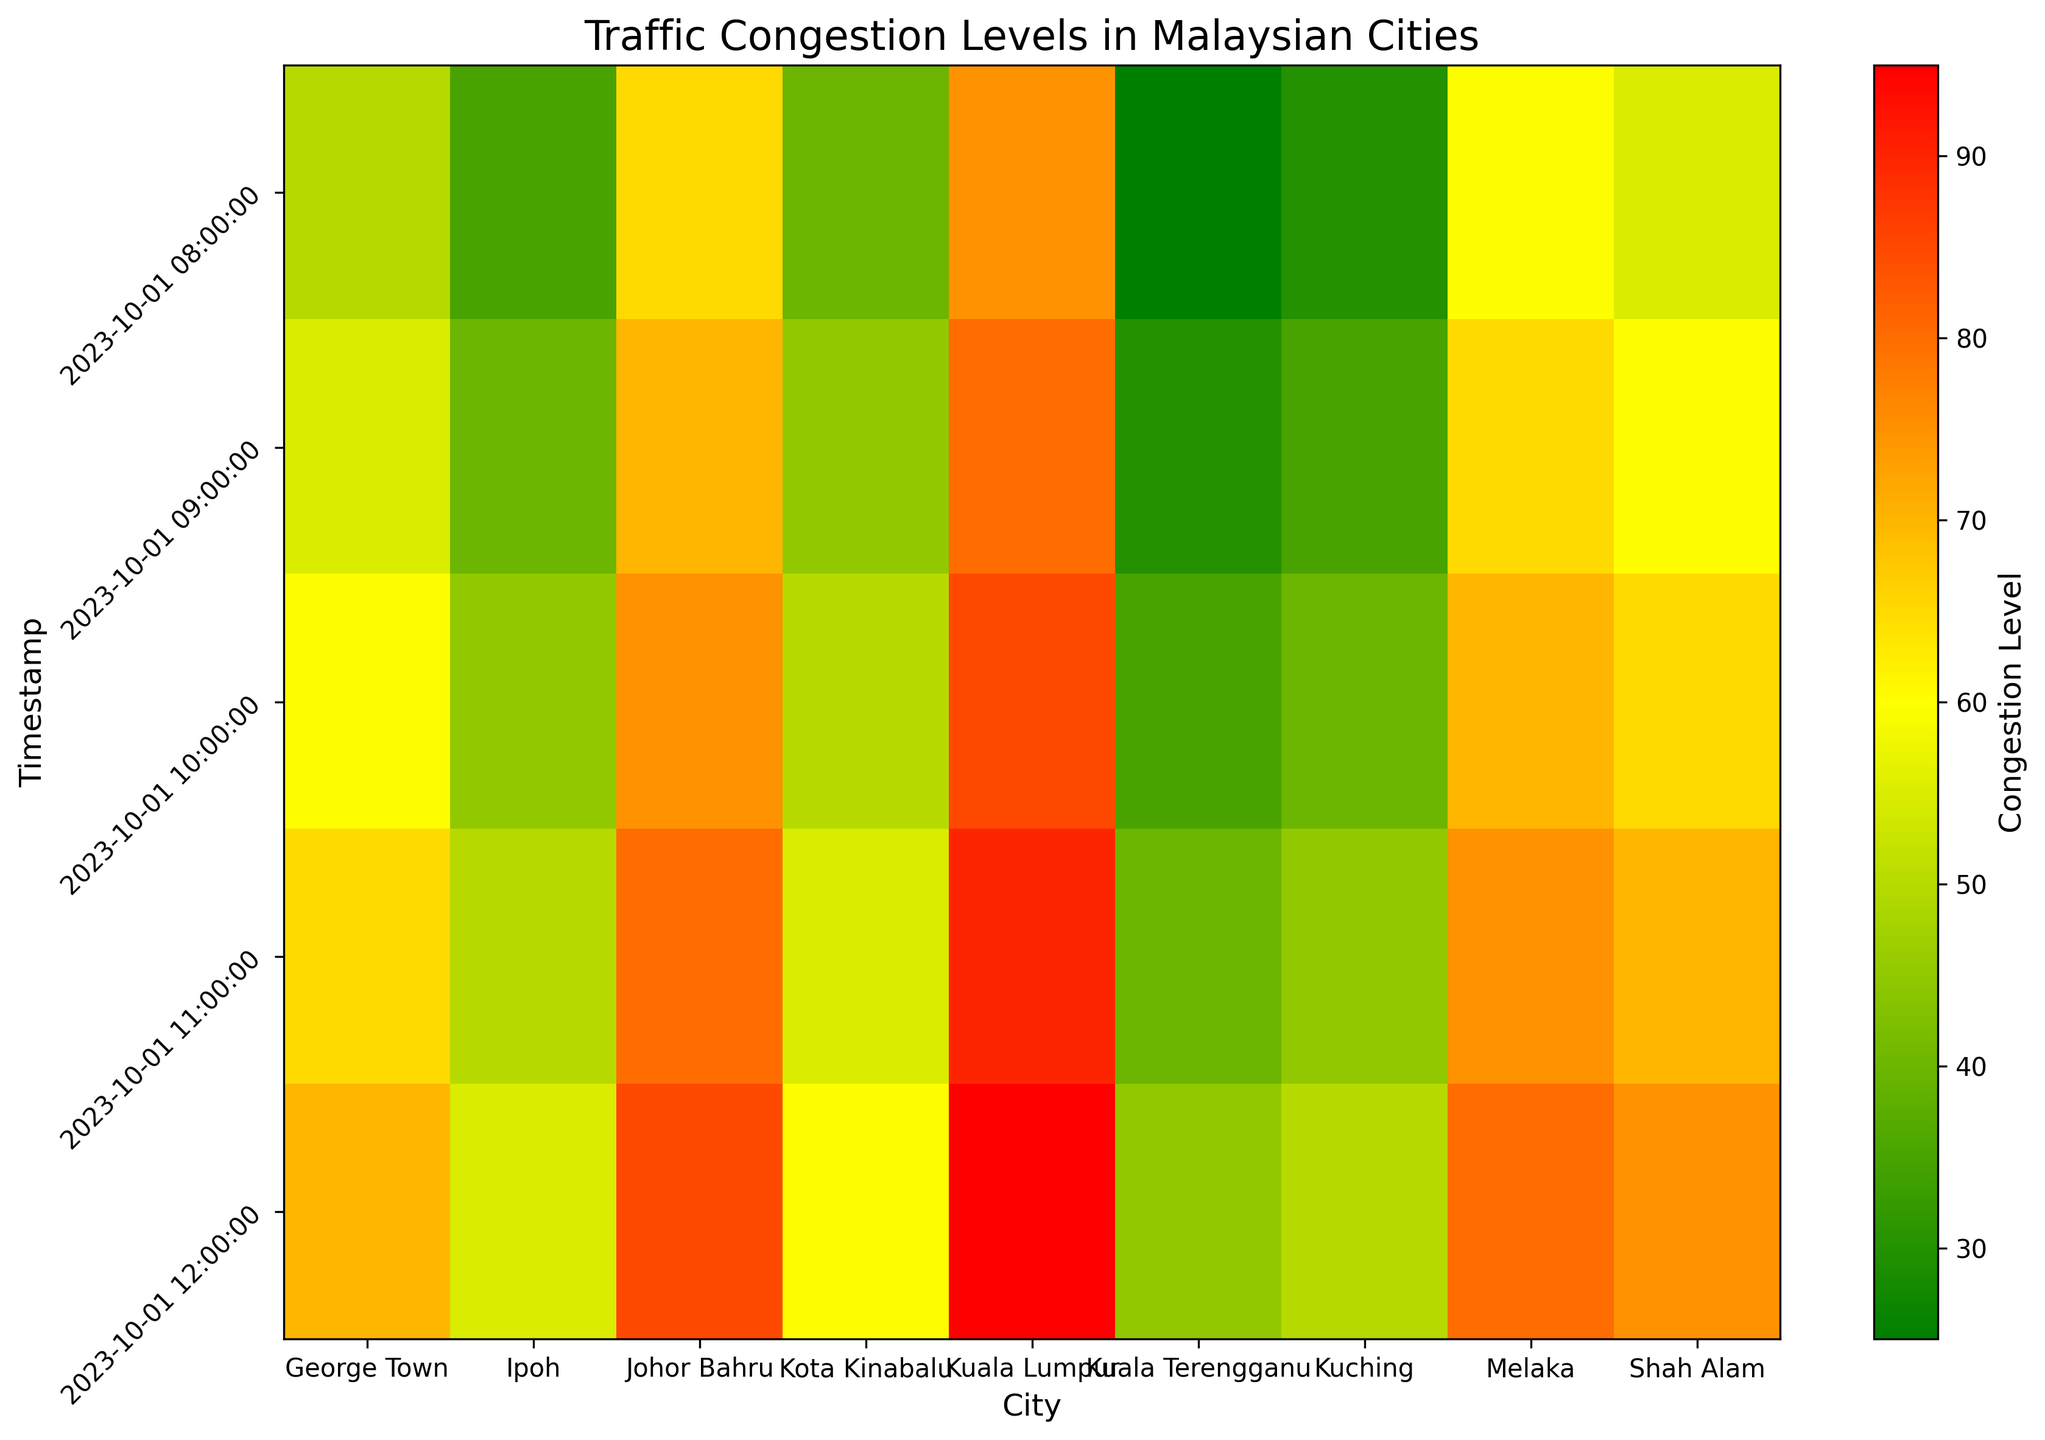What's the average congestion level for Kuala Lumpur between 8:00 and 12:00? Firstly, identify the congestion levels at each time point for Kuala Lumpur: 75, 80, 85, 90, 95. Sum these values: 75 + 80 + 85 + 90 + 95 = 425. There are 5 data points, so divide the total by the number of data points: 425 / 5 = 85.
Answer: 85 Which city shows the highest congestion level at 12:00? At the 12:00 timestamp, compare the congestion levels of all cities. The highest value is 95, which corresponds to Kuala Lumpur.
Answer: Kuala Lumpur In which city did the congestion level increase the most from 8:00 to 12:00? Calculate the increase in congestion level for each city from 8:00 to 12:00 by subtracting the value at 8:00 from the value at 12:00. Kuala Lumpur increased from 75 to 95 which is 20. George Town increased from 50 to 70 which is 20. Ipoh increased from 35 to 55 which is 20. Johor Bahru increased from 65 to 85 which is 20. Kota Kinabalu increased from 40 to 60 which is 20. Shah Alam increased from 55 to 75 which is 20. Melaka increased from 60 to 80 which is 20. Kuching increased from 30 to 50 which is 20. Kuala Terengganu increased from 25 to 45 which is 20. This means all cities increased their congestion level by 20 units.
Answer: All cities Which city has the lowest average congestion level over the given time period? Calculate the average congestion level for each city by summing their congestion values and dividing by the number of time points. The city with the lowest average value is Kuching.
Answer: Kuching At what time did Melaka first reach a congestion level of 70? Observe the heatmap values for Melaka and identify the first timestamp where the congestion level reaches 70. Melaka reached 70 at 10:00.
Answer: 10:00 